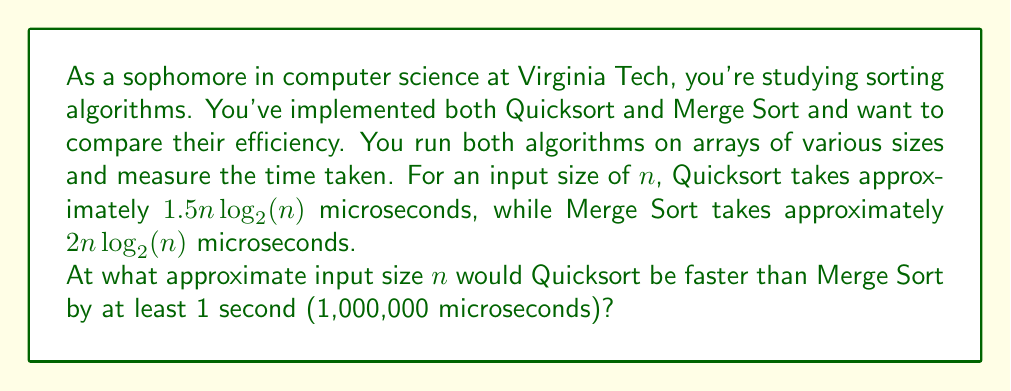Teach me how to tackle this problem. Let's approach this step-by-step:

1) First, we need to set up an inequality where the difference between Merge Sort and Quicksort is at least 1,000,000 microseconds:

   $2n\log_2(n) - 1.5n\log_2(n) \geq 1,000,000$

2) Simplify the left side of the inequality:

   $0.5n\log_2(n) \geq 1,000,000$

3) Divide both sides by 0.5:

   $n\log_2(n) \geq 2,000,000$

4) This equation can't be solved algebraically, so we need to use a numerical method or guess and check.

5) Let's try some values:

   For $n = 100,000$:
   $100,000 \log_2(100,000) \approx 1,660,964$ (too small)

   For $n = 200,000$:
   $200,000 \log_2(200,000) \approx 3,591,928$ (exceeds 2,000,000)

6) The answer lies between 100,000 and 200,000. Through further trial and error or binary search, we can find that the smallest integer value of $n$ that satisfies the inequality is approximately 131,000.

Therefore, Quicksort would be faster than Merge Sort by at least 1 second when the input size is approximately 131,000 elements or greater.
Answer: Approximately 131,000 elements 